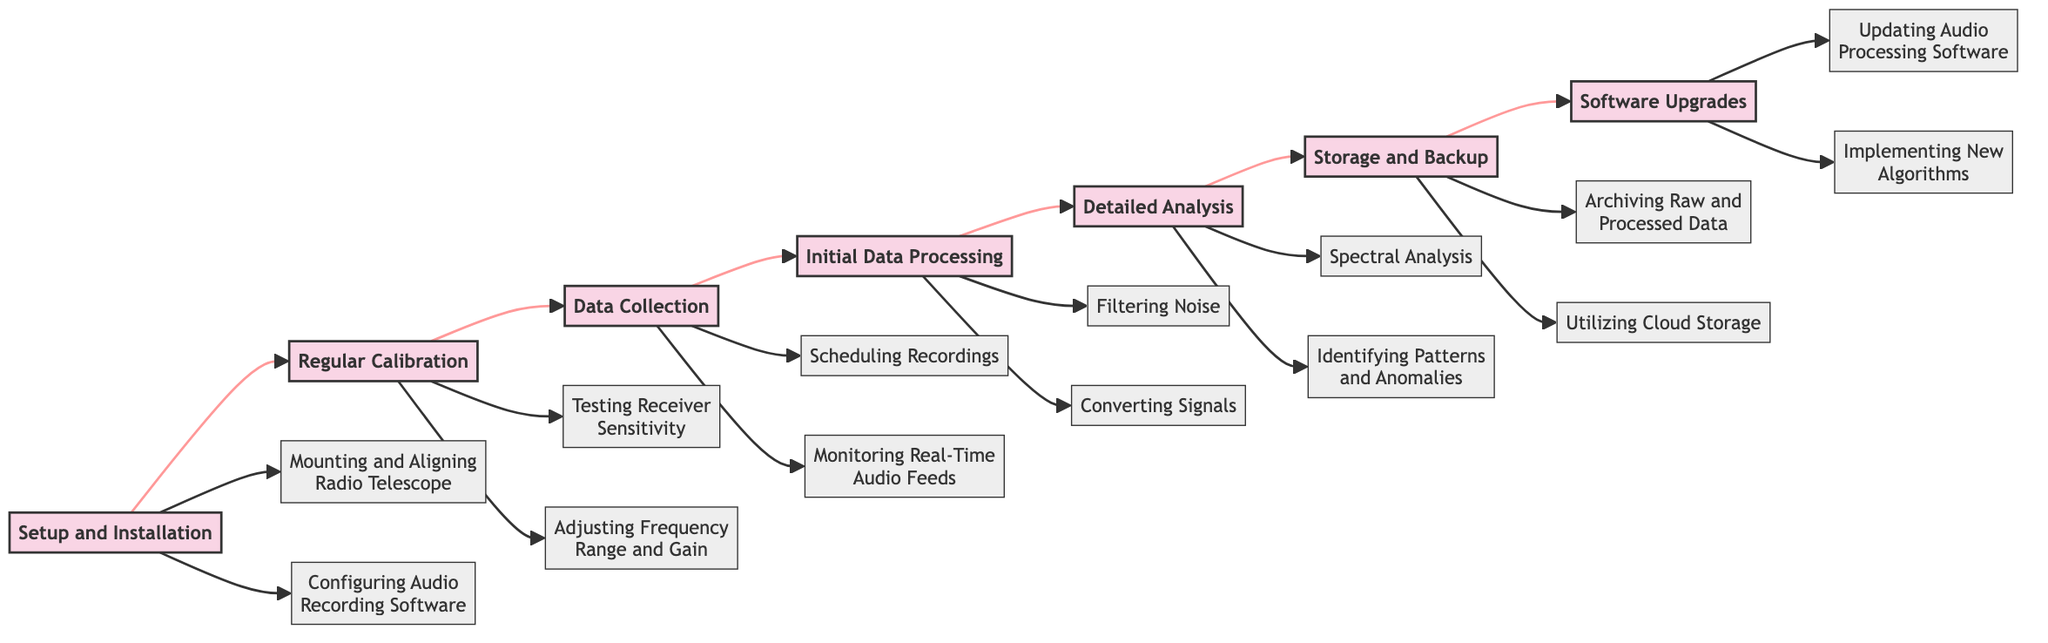What is the first stage in the flowchart? The first stage is labeled "Setup and Installation," which is the starting point of the flowchart.
Answer: Setup and Installation How many stages are there in total? By counting each distinct stage from the flowchart, we find there are seven stages.
Answer: 7 Which activities are associated with regular calibration? The activities linked to regular calibration are "Testing Receiver Sensitivity with Known Signals" and "Adjusting Frequency Range and Signal Gain."
Answer: Testing Receiver Sensitivity with Known Signals, Adjusting Frequency Range and Signal Gain What is the last stage before software upgrades? The stage immediately preceding "Software Upgrades" is "Storage and Backup." This reflects the flow of the chart leading into software maintenance efforts.
Answer: Storage and Backup Which two activities come after data collection? After "Data Collection," the activities are "Initial Data Processing," which includes two specific tasks: "Filtering Noise from Recordings" and "Converting Signals to Appropriate Formats."
Answer: Initial Data Processing What is the relationship between detailed analysis and data collection? The relationship is sequential; "Data Collection" flows directly into "Detailed Analysis," indicating that collected data is subjected to thorough scrutiny next.
Answer: Sequential flow How many activities are associated with initial data processing? Initial data processing comprises two specific activities, which are to filter noise and convert signals.
Answer: 2 What is the second activity associated with setup and installation? The second activity related to "Setup and Installation" is "Configuring the Audio Recording Software." This suggests it follows the initial mounting and alignment activity.
Answer: Configuring Audio Recording Software What stage follows detailed analysis? The stage that follows "Detailed Analysis" is "Storage and Backup," highlighting the progression in the process.
Answer: Storage and Backup 